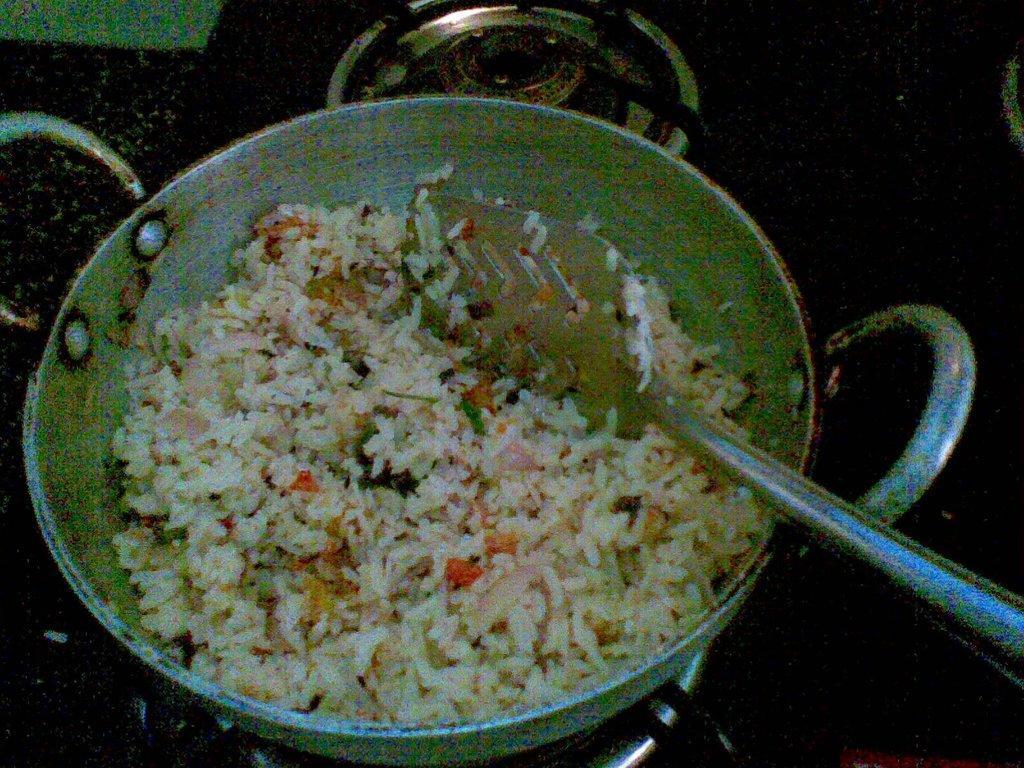Please provide a concise description of this image. In the foreground of this image, there is a pan with some food and a spatula on it and this is placed on a stove. 